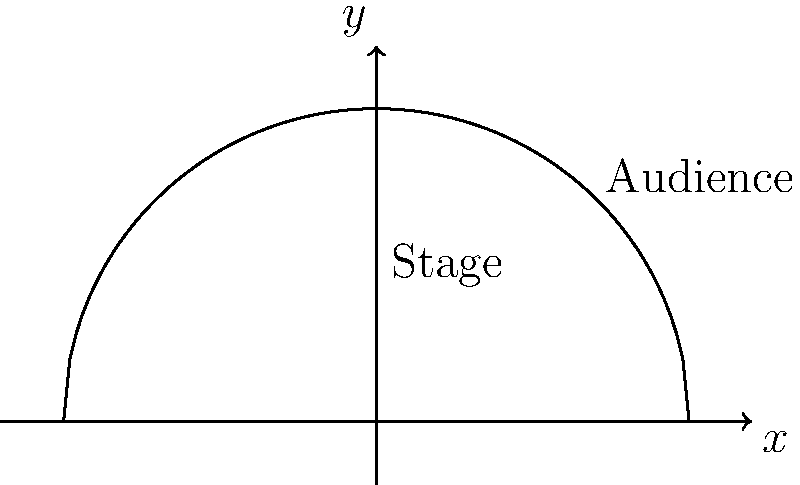Adam DeVine is planning a surprise concert for his fans, and you're tasked with designing the optimal stage shape. The stage needs to be semicircular, and the audience will be arranged in a semicircle around it. If the total perimeter (stage front + audience arc) is fixed at $L$, find the radius $r$ of the stage that maximizes the audience area. Use the calculus of variations to solve this problem, keeping in mind that the solution should be music to Adam's ears! Let's approach this step-by-step, humming along as we go:

1) Let the radius of the stage be $r$ and the radius of the audience semicircle be $R$.

2) The total fixed perimeter $L$ is given by:
   $$L = \pi r + \pi R$$

3) The audience area $A$ is:
   $$A = \frac{1}{2}\pi(R^2 - r^2)$$

4) From the perimeter equation, we can express $R$ in terms of $r$:
   $$R = \frac{L}{\pi} - r$$

5) Substituting this into the area equation:
   $$A = \frac{1}{2}\pi((\frac{L}{\pi} - r)^2 - r^2)$$

6) To maximize $A$, we differentiate with respect to $r$ and set it to zero:
   $$\frac{dA}{dr} = \frac{1}{2}\pi(2(\frac{L}{\pi} - r)(-1) - 2r) = 0$$

7) Simplifying:
   $$-\frac{L}{\pi} + r - r = 0$$
   $$-\frac{L}{\pi} + 2r = 0$$

8) Solving for $r$:
   $$r = \frac{L}{2\pi}$$

9) This critical point maximizes the area because the second derivative is negative.

10) The optimal radius of the stage is $\frac{L}{2\pi}$, which is one-fourth of the total perimeter $L$.
Answer: $r = \frac{L}{2\pi}$ 